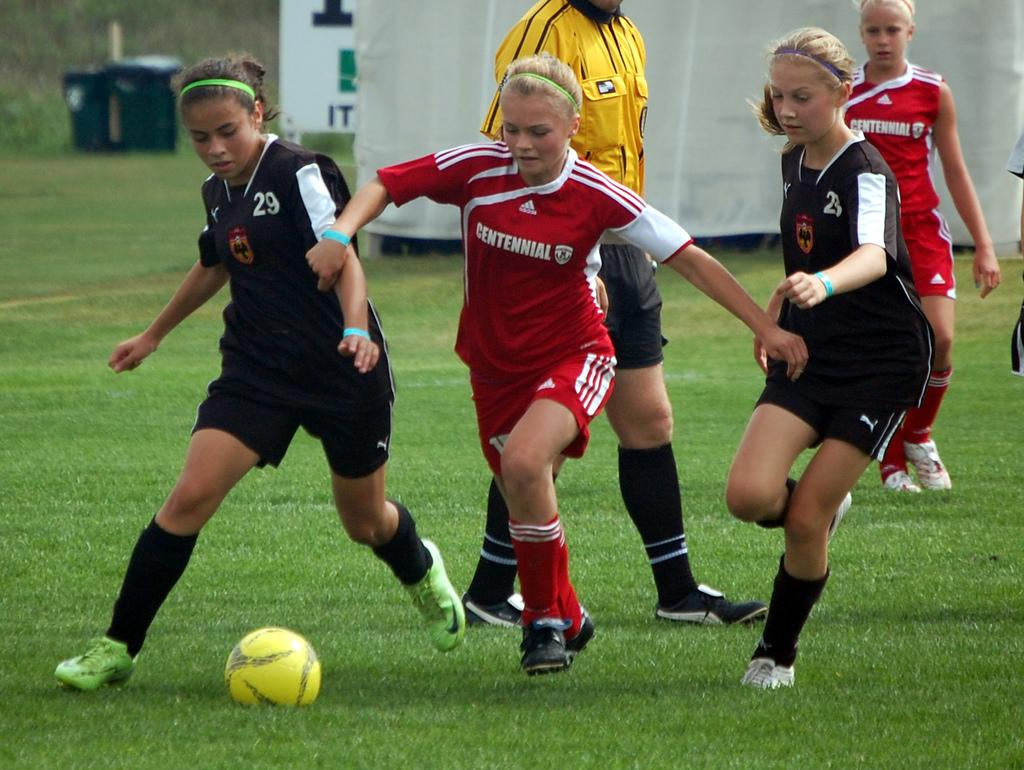<image>
Give a short and clear explanation of the subsequent image. A young girls soccer league wearing a red uniform from Centennial. 